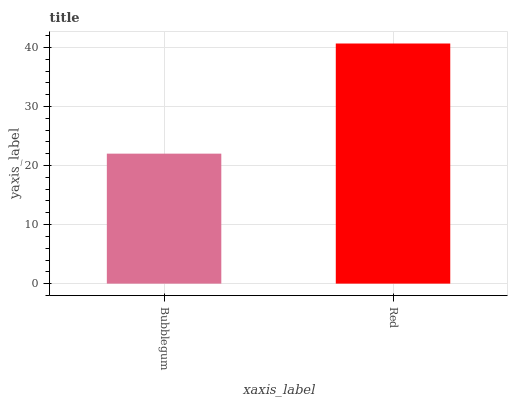Is Bubblegum the minimum?
Answer yes or no. Yes. Is Red the maximum?
Answer yes or no. Yes. Is Red the minimum?
Answer yes or no. No. Is Red greater than Bubblegum?
Answer yes or no. Yes. Is Bubblegum less than Red?
Answer yes or no. Yes. Is Bubblegum greater than Red?
Answer yes or no. No. Is Red less than Bubblegum?
Answer yes or no. No. Is Red the high median?
Answer yes or no. Yes. Is Bubblegum the low median?
Answer yes or no. Yes. Is Bubblegum the high median?
Answer yes or no. No. Is Red the low median?
Answer yes or no. No. 